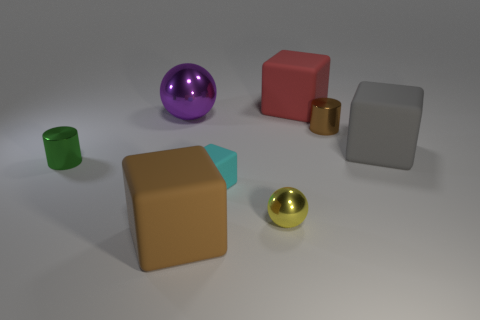Add 1 tiny blue blocks. How many objects exist? 9 Subtract all cylinders. How many objects are left? 6 Subtract all metal cylinders. Subtract all shiny things. How many objects are left? 2 Add 8 big purple things. How many big purple things are left? 9 Add 5 small yellow spheres. How many small yellow spheres exist? 6 Subtract 0 cyan spheres. How many objects are left? 8 